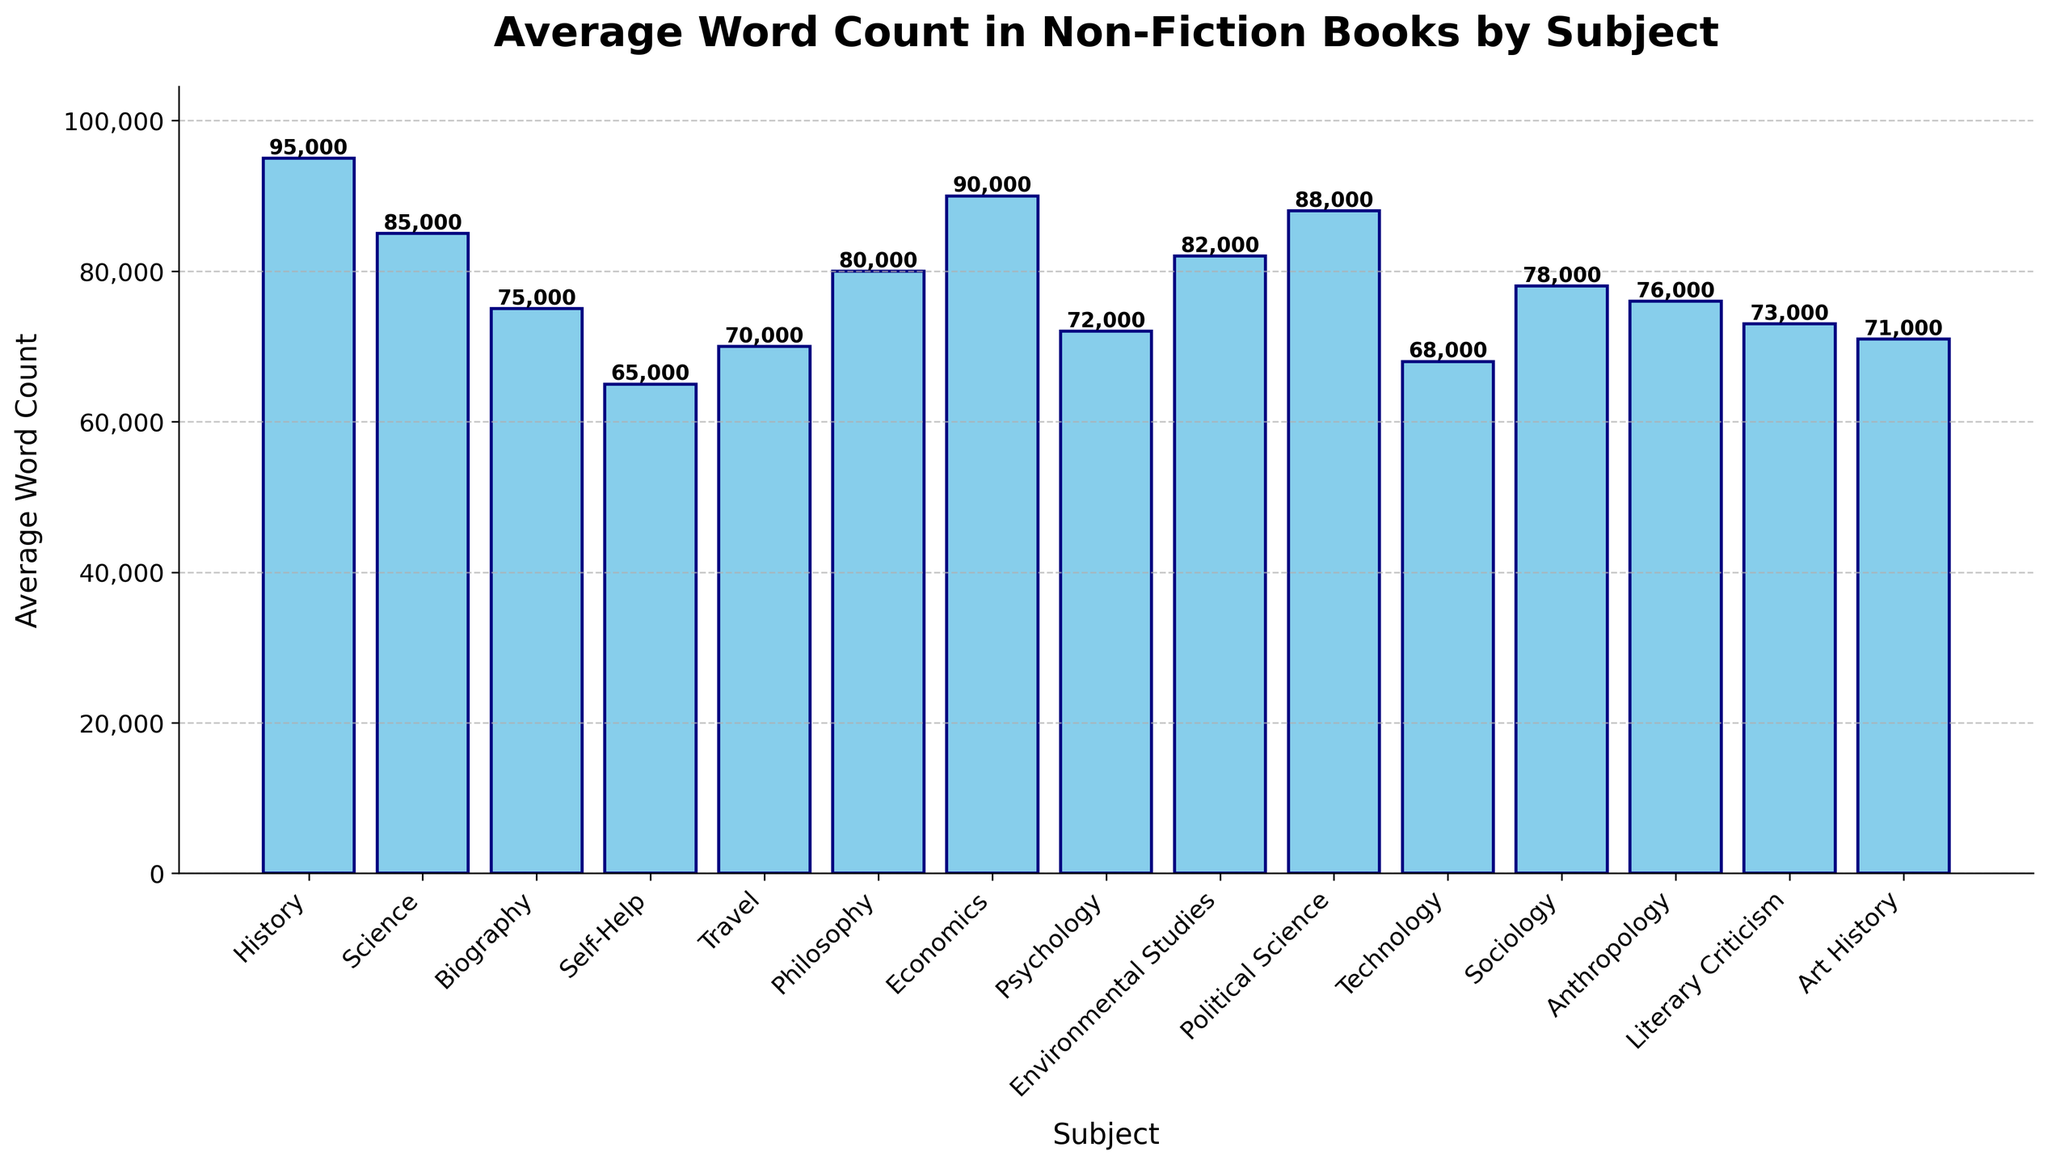Which subject has the highest average word count? The highest bar indicates the subject with the highest average word count. Upon examining the bars, History has the tallest bar.
Answer: History Which subject has the lowest average word count? The shortest bar represents the subject with the lowest average word count. The Self-Help bar is visually the shortest.
Answer: Self-Help What is the difference in average word count between History and Science? Find the heights of the bars for History and Science, then subtract the average word count of Science from History. History is 95,000, and Science is 85,000. The difference is 95,000 - 85,000.
Answer: 10,000 What are the two subjects with average word counts closest to each other? Compare the distances between the tops of the bars. Philosophy (80,000) and Environmental Studies (82,000) have the smallest difference in word count.
Answer: Philosophy and Environmental Studies Which subjects have an average word count greater than 80,000? Identify the bars exceeding the 80,000-mark. These subjects are History, Science, Economics, Political Science, History, and Environmental Studies.
Answer: History, Science, Economics, Political Science, Environmental Studies List the subjects that have an average word count of less than 75,000. Check the bars below the 75,000-mark, which include Travel, Technology, Self-Help, Psychology, and Literary Criticism.
Answer: Travel, Technology, Self-Help, Psychology, Literary Criticism What's the combined average word count of the subjects with the second and third highest values? Identify the second and third highest bars: Political Science (88,000) and Economics (90,000). Add them: 88,000 + 90,000.
Answer: 178,000 Which subject has the median average word count? Sort the subjects by average word counts and find the middle value. After ordering, the median word count is Sociology (78,000).
Answer: Sociology How many subjects have an average word count between 70,000 and 80,000? Count the bars whose heights fall within this range. Identified subjects are Technology, Literary Criticism, Travel, Psychology, Biography, Sociology, and Art History.
Answer: 7 What is the average word count of all subjects combined? Sum the average word counts of all subjects and divide by the number of subjects: (95,000 + 85,000 + 75,000 + 65,000 + 70,000 + 80,000 + 90,000 + 72,000 + 82,000 + 88,000 + 68,000 + 78,000 + 76,000 + 73,000 + 71,000)/15
Answer: 77,067 